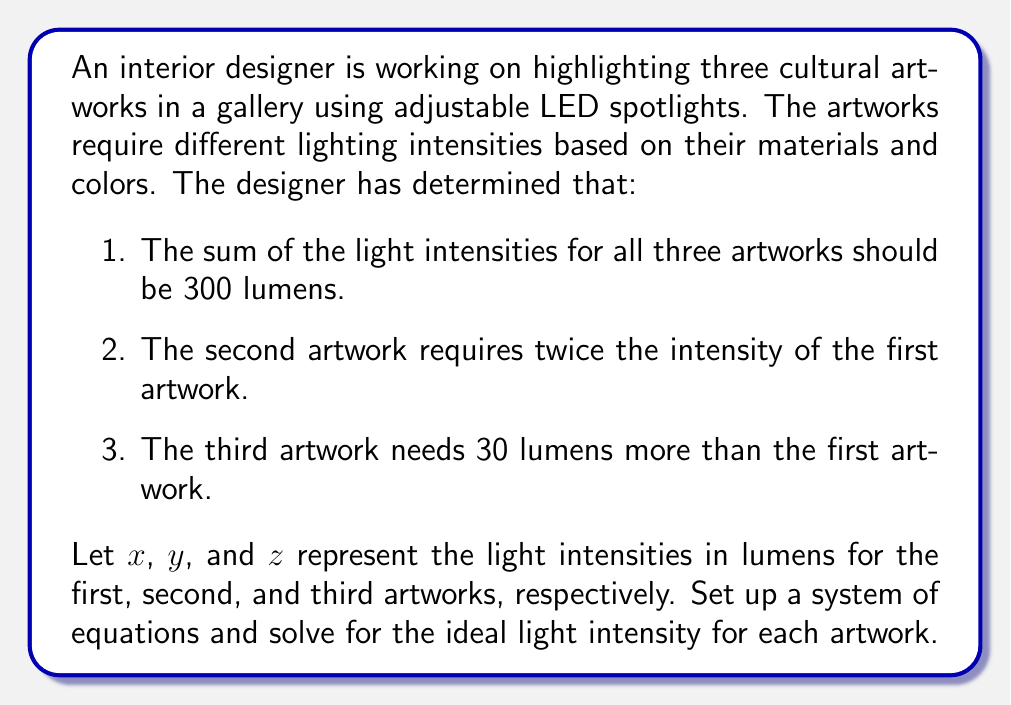Can you solve this math problem? To solve this problem, we'll set up a system of three equations based on the given information and then solve them step-by-step.

1. From the first condition: $x + y + z = 300$
2. From the second condition: $y = 2x$
3. From the third condition: $z = x + 30$

Now we have the system of equations:

$$\begin{cases}
x + y + z = 300 \\
y = 2x \\
z = x + 30
\end{cases}$$

Let's solve this system by substitution:

1. Substitute the expressions for $y$ and $z$ into the first equation:
   $x + 2x + (x + 30) = 300$

2. Simplify:
   $4x + 30 = 300$

3. Subtract 30 from both sides:
   $4x = 270$

4. Divide both sides by 4:
   $x = 67.5$

Now that we know $x$, we can find $y$ and $z$:

5. Calculate $y$:
   $y = 2x = 2(67.5) = 135$

6. Calculate $z$:
   $z = x + 30 = 67.5 + 30 = 97.5$

7. Verify the solution by checking if the sum equals 300:
   $67.5 + 135 + 97.5 = 300$ (correct)

Therefore, the ideal light intensities for the three artworks are:
- First artwork (x): 67.5 lumens
- Second artwork (y): 135 lumens
- Third artwork (z): 97.5 lumens
Answer: The ideal light intensities for the three artworks are:
First artwork: 67.5 lumens
Second artwork: 135 lumens
Third artwork: 97.5 lumens 